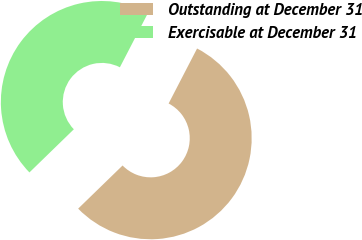Convert chart to OTSL. <chart><loc_0><loc_0><loc_500><loc_500><pie_chart><fcel>Outstanding at December 31<fcel>Exercisable at December 31<nl><fcel>55.13%<fcel>44.87%<nl></chart> 